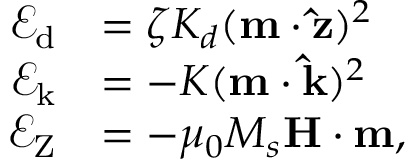Convert formula to latex. <formula><loc_0><loc_0><loc_500><loc_500>\begin{array} { r l } { \mathcal { E } _ { d } } & { = \zeta K _ { d } ( m \cdot \hat { z } ) ^ { 2 } } \\ { \mathcal { E } _ { k } } & { = - K ( m \cdot \hat { k } ) ^ { 2 } } \\ { \mathcal { E } _ { Z } } & { = - \mu _ { 0 } M _ { s } H \cdot m , } \end{array}</formula> 